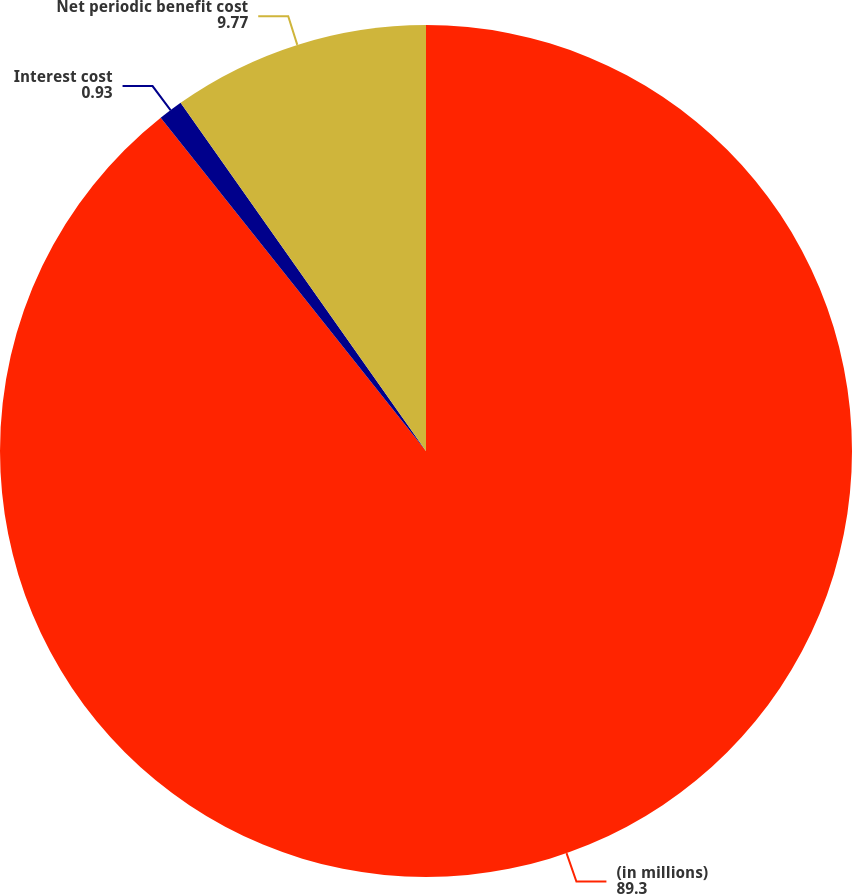Convert chart to OTSL. <chart><loc_0><loc_0><loc_500><loc_500><pie_chart><fcel>(in millions)<fcel>Interest cost<fcel>Net periodic benefit cost<nl><fcel>89.3%<fcel>0.93%<fcel>9.77%<nl></chart> 